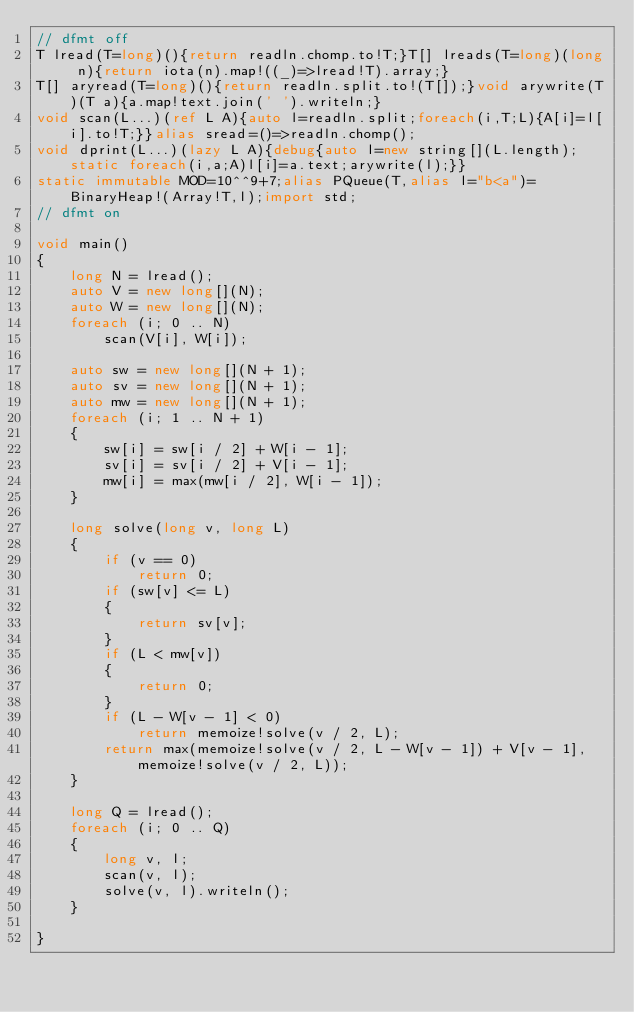<code> <loc_0><loc_0><loc_500><loc_500><_D_>// dfmt off
T lread(T=long)(){return readln.chomp.to!T;}T[] lreads(T=long)(long n){return iota(n).map!((_)=>lread!T).array;}
T[] aryread(T=long)(){return readln.split.to!(T[]);}void arywrite(T)(T a){a.map!text.join(' ').writeln;}
void scan(L...)(ref L A){auto l=readln.split;foreach(i,T;L){A[i]=l[i].to!T;}}alias sread=()=>readln.chomp();
void dprint(L...)(lazy L A){debug{auto l=new string[](L.length);static foreach(i,a;A)l[i]=a.text;arywrite(l);}}
static immutable MOD=10^^9+7;alias PQueue(T,alias l="b<a")=BinaryHeap!(Array!T,l);import std;
// dfmt on

void main()
{
    long N = lread();
    auto V = new long[](N);
    auto W = new long[](N);
    foreach (i; 0 .. N)
        scan(V[i], W[i]);

    auto sw = new long[](N + 1);
    auto sv = new long[](N + 1);
    auto mw = new long[](N + 1);
    foreach (i; 1 .. N + 1)
    {
        sw[i] = sw[i / 2] + W[i - 1];
        sv[i] = sv[i / 2] + V[i - 1];
        mw[i] = max(mw[i / 2], W[i - 1]);
    }

    long solve(long v, long L)
    {
        if (v == 0)
            return 0;
        if (sw[v] <= L)
        {
            return sv[v];
        }
        if (L < mw[v])
        {
            return 0;
        }
        if (L - W[v - 1] < 0)
            return memoize!solve(v / 2, L);
        return max(memoize!solve(v / 2, L - W[v - 1]) + V[v - 1], memoize!solve(v / 2, L));
    }

    long Q = lread();
    foreach (i; 0 .. Q)
    {
        long v, l;
        scan(v, l);
        solve(v, l).writeln();
    }

}
</code> 